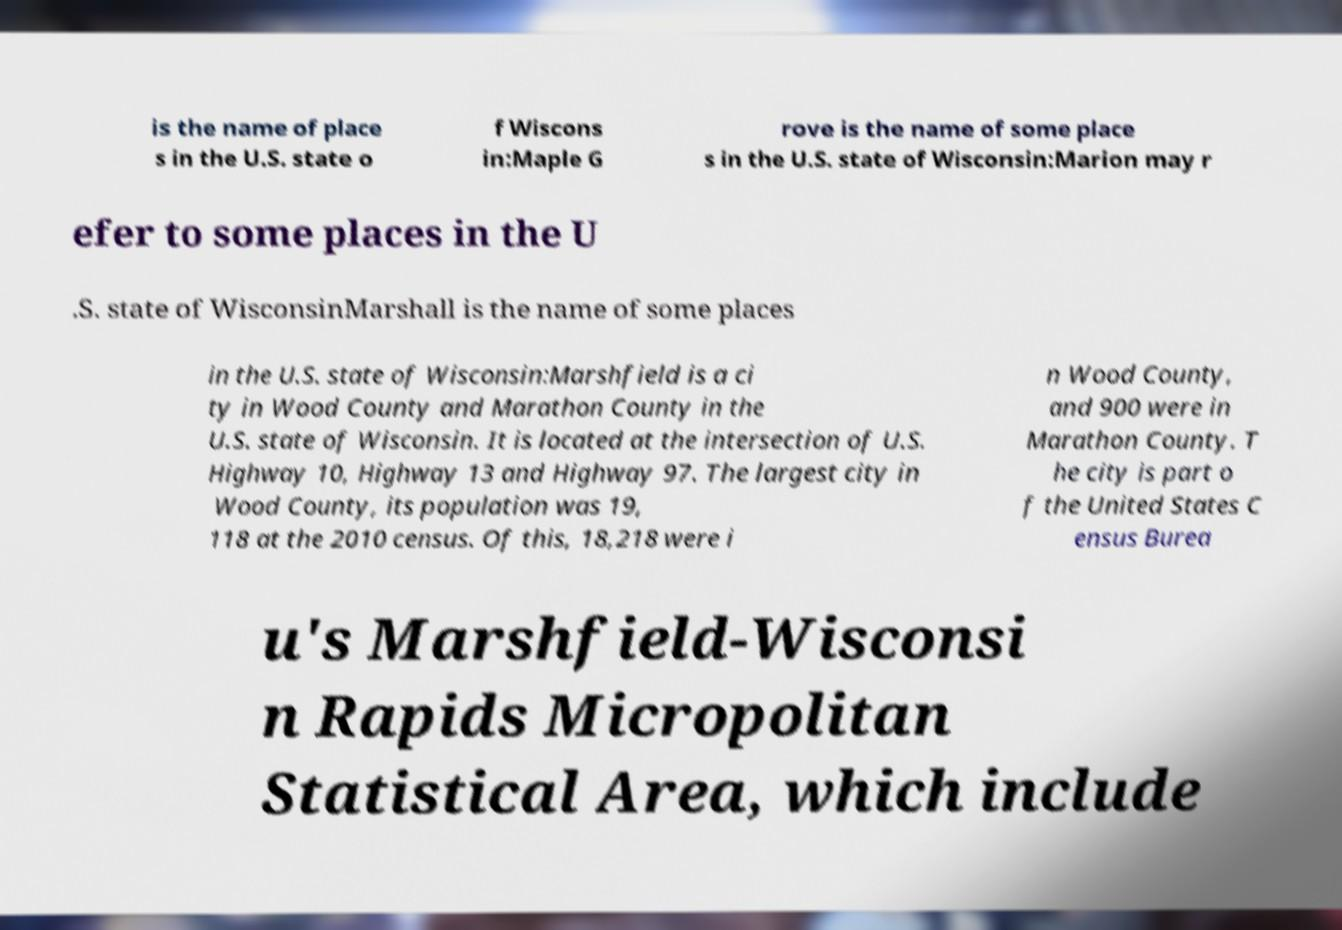Could you extract and type out the text from this image? is the name of place s in the U.S. state o f Wiscons in:Maple G rove is the name of some place s in the U.S. state of Wisconsin:Marion may r efer to some places in the U .S. state of WisconsinMarshall is the name of some places in the U.S. state of Wisconsin:Marshfield is a ci ty in Wood County and Marathon County in the U.S. state of Wisconsin. It is located at the intersection of U.S. Highway 10, Highway 13 and Highway 97. The largest city in Wood County, its population was 19, 118 at the 2010 census. Of this, 18,218 were i n Wood County, and 900 were in Marathon County. T he city is part o f the United States C ensus Burea u's Marshfield-Wisconsi n Rapids Micropolitan Statistical Area, which include 